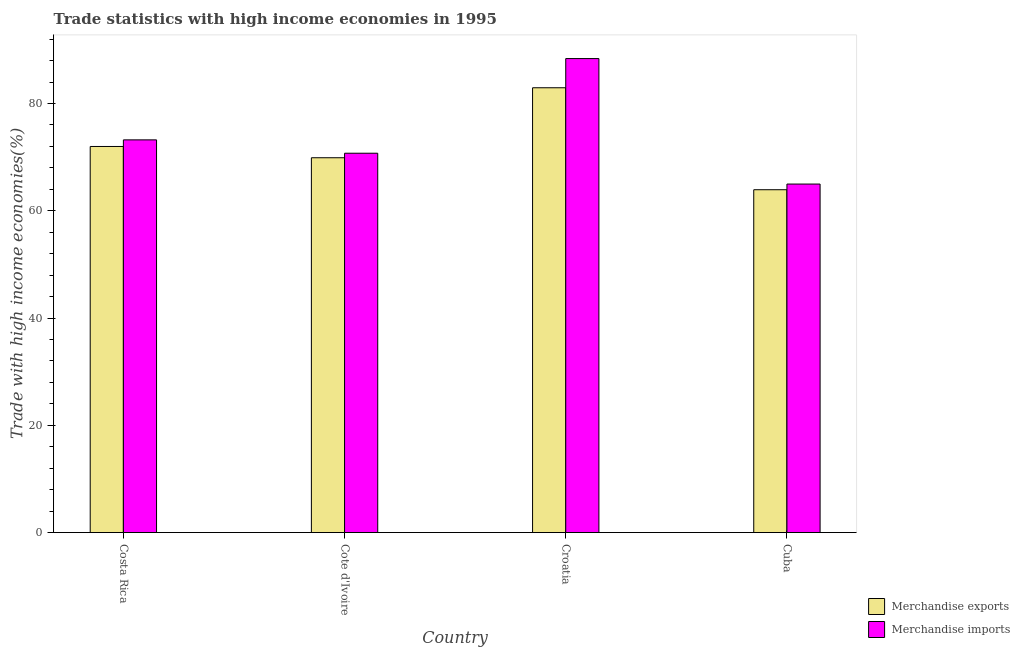How many different coloured bars are there?
Make the answer very short. 2. Are the number of bars on each tick of the X-axis equal?
Provide a short and direct response. Yes. What is the label of the 1st group of bars from the left?
Provide a short and direct response. Costa Rica. In how many cases, is the number of bars for a given country not equal to the number of legend labels?
Give a very brief answer. 0. What is the merchandise imports in Costa Rica?
Ensure brevity in your answer.  73.22. Across all countries, what is the maximum merchandise imports?
Your response must be concise. 88.37. Across all countries, what is the minimum merchandise imports?
Offer a very short reply. 64.98. In which country was the merchandise imports maximum?
Ensure brevity in your answer.  Croatia. In which country was the merchandise exports minimum?
Ensure brevity in your answer.  Cuba. What is the total merchandise exports in the graph?
Your response must be concise. 288.73. What is the difference between the merchandise exports in Costa Rica and that in Cote d'Ivoire?
Offer a very short reply. 2.1. What is the difference between the merchandise imports in Cuba and the merchandise exports in Cote d'Ivoire?
Your response must be concise. -4.91. What is the average merchandise imports per country?
Keep it short and to the point. 74.32. What is the difference between the merchandise exports and merchandise imports in Cuba?
Provide a short and direct response. -1.06. In how many countries, is the merchandise imports greater than 48 %?
Provide a succinct answer. 4. What is the ratio of the merchandise imports in Costa Rica to that in Cote d'Ivoire?
Give a very brief answer. 1.04. Is the merchandise imports in Cote d'Ivoire less than that in Cuba?
Provide a succinct answer. No. What is the difference between the highest and the second highest merchandise exports?
Keep it short and to the point. 10.95. What is the difference between the highest and the lowest merchandise imports?
Keep it short and to the point. 23.39. In how many countries, is the merchandise exports greater than the average merchandise exports taken over all countries?
Ensure brevity in your answer.  1. How many bars are there?
Your answer should be very brief. 8. How many countries are there in the graph?
Your response must be concise. 4. Are the values on the major ticks of Y-axis written in scientific E-notation?
Offer a terse response. No. Does the graph contain any zero values?
Give a very brief answer. No. Does the graph contain grids?
Provide a succinct answer. No. Where does the legend appear in the graph?
Offer a very short reply. Bottom right. How are the legend labels stacked?
Your answer should be very brief. Vertical. What is the title of the graph?
Provide a succinct answer. Trade statistics with high income economies in 1995. Does "Birth rate" appear as one of the legend labels in the graph?
Your answer should be very brief. No. What is the label or title of the X-axis?
Offer a very short reply. Country. What is the label or title of the Y-axis?
Ensure brevity in your answer.  Trade with high income economies(%). What is the Trade with high income economies(%) of Merchandise exports in Costa Rica?
Your answer should be very brief. 71.99. What is the Trade with high income economies(%) of Merchandise imports in Costa Rica?
Give a very brief answer. 73.22. What is the Trade with high income economies(%) in Merchandise exports in Cote d'Ivoire?
Ensure brevity in your answer.  69.88. What is the Trade with high income economies(%) of Merchandise imports in Cote d'Ivoire?
Your answer should be compact. 70.73. What is the Trade with high income economies(%) of Merchandise exports in Croatia?
Keep it short and to the point. 82.93. What is the Trade with high income economies(%) of Merchandise imports in Croatia?
Give a very brief answer. 88.37. What is the Trade with high income economies(%) of Merchandise exports in Cuba?
Give a very brief answer. 63.92. What is the Trade with high income economies(%) in Merchandise imports in Cuba?
Your answer should be compact. 64.98. Across all countries, what is the maximum Trade with high income economies(%) in Merchandise exports?
Provide a short and direct response. 82.93. Across all countries, what is the maximum Trade with high income economies(%) in Merchandise imports?
Your answer should be compact. 88.37. Across all countries, what is the minimum Trade with high income economies(%) in Merchandise exports?
Give a very brief answer. 63.92. Across all countries, what is the minimum Trade with high income economies(%) in Merchandise imports?
Offer a very short reply. 64.98. What is the total Trade with high income economies(%) in Merchandise exports in the graph?
Ensure brevity in your answer.  288.73. What is the total Trade with high income economies(%) of Merchandise imports in the graph?
Your response must be concise. 297.29. What is the difference between the Trade with high income economies(%) in Merchandise exports in Costa Rica and that in Cote d'Ivoire?
Keep it short and to the point. 2.1. What is the difference between the Trade with high income economies(%) in Merchandise imports in Costa Rica and that in Cote d'Ivoire?
Give a very brief answer. 2.49. What is the difference between the Trade with high income economies(%) of Merchandise exports in Costa Rica and that in Croatia?
Your answer should be compact. -10.95. What is the difference between the Trade with high income economies(%) of Merchandise imports in Costa Rica and that in Croatia?
Offer a very short reply. -15.16. What is the difference between the Trade with high income economies(%) in Merchandise exports in Costa Rica and that in Cuba?
Provide a succinct answer. 8.06. What is the difference between the Trade with high income economies(%) of Merchandise imports in Costa Rica and that in Cuba?
Provide a short and direct response. 8.24. What is the difference between the Trade with high income economies(%) of Merchandise exports in Cote d'Ivoire and that in Croatia?
Your answer should be very brief. -13.05. What is the difference between the Trade with high income economies(%) in Merchandise imports in Cote d'Ivoire and that in Croatia?
Provide a short and direct response. -17.65. What is the difference between the Trade with high income economies(%) of Merchandise exports in Cote d'Ivoire and that in Cuba?
Give a very brief answer. 5.96. What is the difference between the Trade with high income economies(%) in Merchandise imports in Cote d'Ivoire and that in Cuba?
Provide a short and direct response. 5.75. What is the difference between the Trade with high income economies(%) in Merchandise exports in Croatia and that in Cuba?
Provide a short and direct response. 19.01. What is the difference between the Trade with high income economies(%) of Merchandise imports in Croatia and that in Cuba?
Your answer should be very brief. 23.39. What is the difference between the Trade with high income economies(%) of Merchandise exports in Costa Rica and the Trade with high income economies(%) of Merchandise imports in Cote d'Ivoire?
Your answer should be very brief. 1.26. What is the difference between the Trade with high income economies(%) in Merchandise exports in Costa Rica and the Trade with high income economies(%) in Merchandise imports in Croatia?
Give a very brief answer. -16.39. What is the difference between the Trade with high income economies(%) of Merchandise exports in Costa Rica and the Trade with high income economies(%) of Merchandise imports in Cuba?
Provide a succinct answer. 7.01. What is the difference between the Trade with high income economies(%) of Merchandise exports in Cote d'Ivoire and the Trade with high income economies(%) of Merchandise imports in Croatia?
Keep it short and to the point. -18.49. What is the difference between the Trade with high income economies(%) in Merchandise exports in Cote d'Ivoire and the Trade with high income economies(%) in Merchandise imports in Cuba?
Ensure brevity in your answer.  4.91. What is the difference between the Trade with high income economies(%) in Merchandise exports in Croatia and the Trade with high income economies(%) in Merchandise imports in Cuba?
Offer a terse response. 17.95. What is the average Trade with high income economies(%) in Merchandise exports per country?
Offer a terse response. 72.18. What is the average Trade with high income economies(%) in Merchandise imports per country?
Offer a very short reply. 74.32. What is the difference between the Trade with high income economies(%) of Merchandise exports and Trade with high income economies(%) of Merchandise imports in Costa Rica?
Ensure brevity in your answer.  -1.23. What is the difference between the Trade with high income economies(%) of Merchandise exports and Trade with high income economies(%) of Merchandise imports in Cote d'Ivoire?
Offer a very short reply. -0.84. What is the difference between the Trade with high income economies(%) in Merchandise exports and Trade with high income economies(%) in Merchandise imports in Croatia?
Provide a short and direct response. -5.44. What is the difference between the Trade with high income economies(%) of Merchandise exports and Trade with high income economies(%) of Merchandise imports in Cuba?
Ensure brevity in your answer.  -1.06. What is the ratio of the Trade with high income economies(%) of Merchandise exports in Costa Rica to that in Cote d'Ivoire?
Your answer should be very brief. 1.03. What is the ratio of the Trade with high income economies(%) in Merchandise imports in Costa Rica to that in Cote d'Ivoire?
Offer a very short reply. 1.04. What is the ratio of the Trade with high income economies(%) in Merchandise exports in Costa Rica to that in Croatia?
Your answer should be very brief. 0.87. What is the ratio of the Trade with high income economies(%) in Merchandise imports in Costa Rica to that in Croatia?
Your answer should be compact. 0.83. What is the ratio of the Trade with high income economies(%) in Merchandise exports in Costa Rica to that in Cuba?
Provide a short and direct response. 1.13. What is the ratio of the Trade with high income economies(%) of Merchandise imports in Costa Rica to that in Cuba?
Give a very brief answer. 1.13. What is the ratio of the Trade with high income economies(%) of Merchandise exports in Cote d'Ivoire to that in Croatia?
Ensure brevity in your answer.  0.84. What is the ratio of the Trade with high income economies(%) of Merchandise imports in Cote d'Ivoire to that in Croatia?
Offer a very short reply. 0.8. What is the ratio of the Trade with high income economies(%) of Merchandise exports in Cote d'Ivoire to that in Cuba?
Provide a succinct answer. 1.09. What is the ratio of the Trade with high income economies(%) in Merchandise imports in Cote d'Ivoire to that in Cuba?
Your answer should be very brief. 1.09. What is the ratio of the Trade with high income economies(%) in Merchandise exports in Croatia to that in Cuba?
Ensure brevity in your answer.  1.3. What is the ratio of the Trade with high income economies(%) of Merchandise imports in Croatia to that in Cuba?
Offer a terse response. 1.36. What is the difference between the highest and the second highest Trade with high income economies(%) of Merchandise exports?
Keep it short and to the point. 10.95. What is the difference between the highest and the second highest Trade with high income economies(%) in Merchandise imports?
Give a very brief answer. 15.16. What is the difference between the highest and the lowest Trade with high income economies(%) of Merchandise exports?
Give a very brief answer. 19.01. What is the difference between the highest and the lowest Trade with high income economies(%) in Merchandise imports?
Offer a terse response. 23.39. 